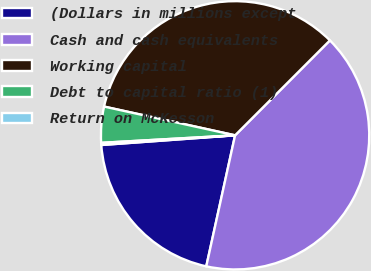Convert chart. <chart><loc_0><loc_0><loc_500><loc_500><pie_chart><fcel>(Dollars in millions except<fcel>Cash and cash equivalents<fcel>Working capital<fcel>Debt to capital ratio (1)<fcel>Return on McKesson<nl><fcel>20.4%<fcel>40.95%<fcel>34.05%<fcel>4.33%<fcel>0.26%<nl></chart> 